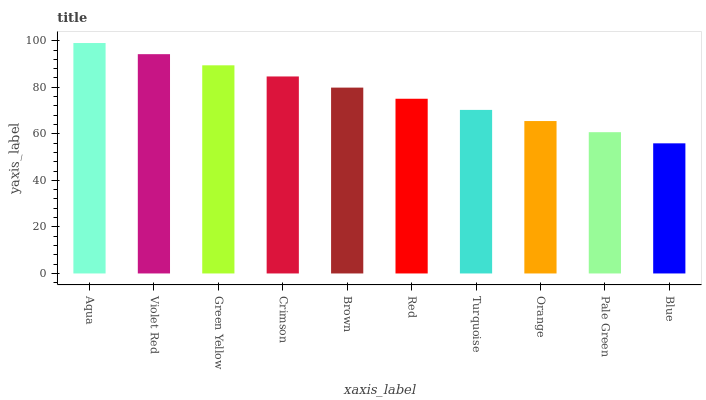Is Blue the minimum?
Answer yes or no. Yes. Is Aqua the maximum?
Answer yes or no. Yes. Is Violet Red the minimum?
Answer yes or no. No. Is Violet Red the maximum?
Answer yes or no. No. Is Aqua greater than Violet Red?
Answer yes or no. Yes. Is Violet Red less than Aqua?
Answer yes or no. Yes. Is Violet Red greater than Aqua?
Answer yes or no. No. Is Aqua less than Violet Red?
Answer yes or no. No. Is Brown the high median?
Answer yes or no. Yes. Is Red the low median?
Answer yes or no. Yes. Is Violet Red the high median?
Answer yes or no. No. Is Green Yellow the low median?
Answer yes or no. No. 